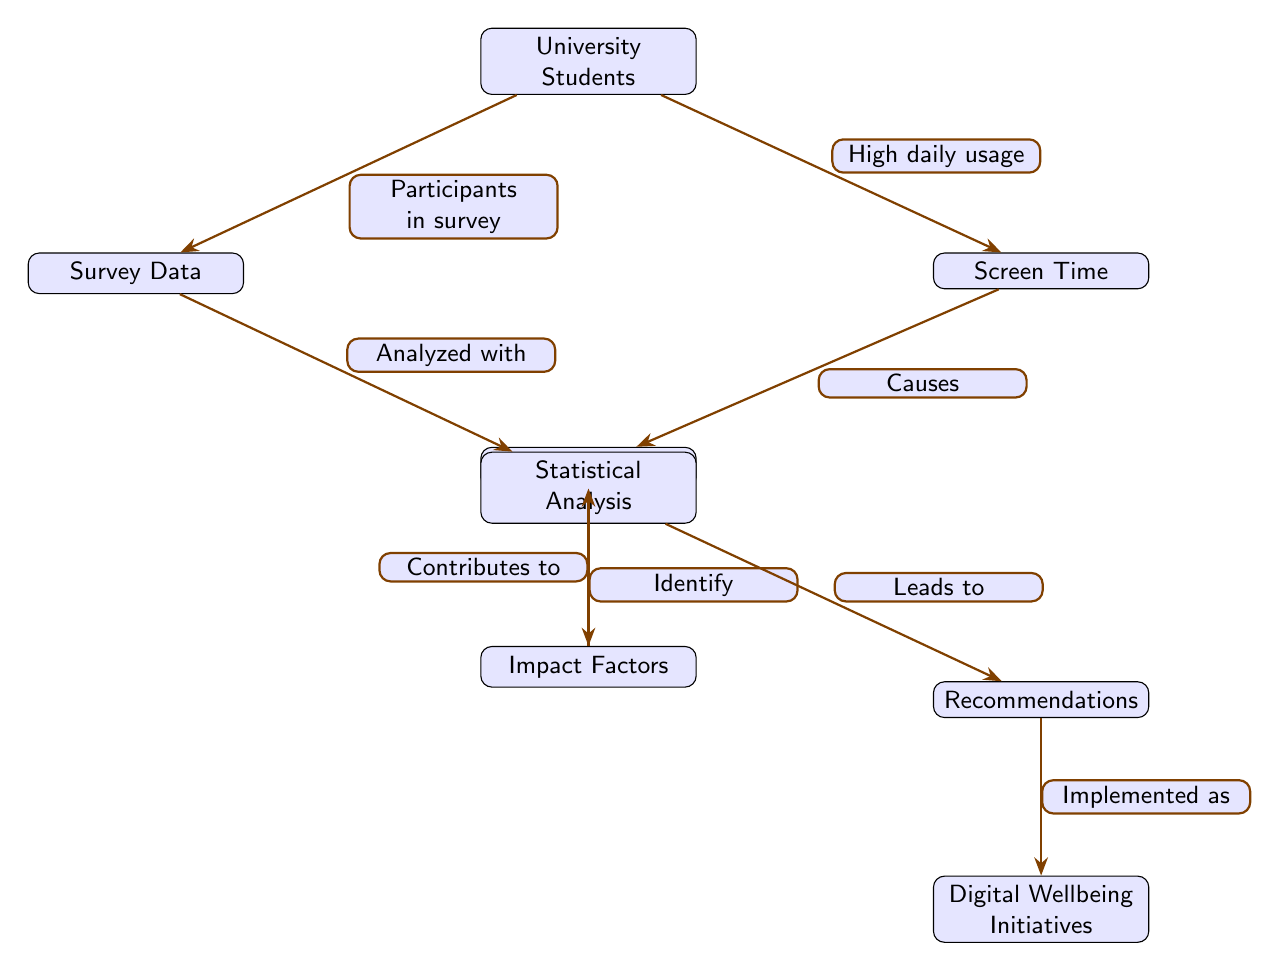What is the main subject of the diagram? The central theme of the diagram is indicated by the first node, which states "University Students." This gives the primary focus of the analysis.
Answer: University Students What are the two main outcomes of high screen time in the diagram? Following the flow from "Screen Time" to the consequences links to the nodes "Blurry Vision" (indicating a direct outcome) and also "Recommendations" (where actions may follow).
Answer: Blurry Vision and Recommendations How many nodes are present in the diagram? Counting all unique elements that represent concepts or categories in the diagram, we find a total of eight nodes listed.
Answer: 8 Which node is connected to both "Survey Data" and "Statistical Analysis"? By examining the connections, "Statistical Analysis" directly connects to "Survey Data," serving as a key link between participant responses and further evaluation.
Answer: Statistical Analysis What causes blurry vision according to the diagram? The connection from the "Screen Time" node to "Blurry Vision" is marked with the word "Causes," indicating that increased screen time leads directly to this symptom.
Answer: Causes What is the relationship between "Statistical Analysis" and "Impact Factors"? The arrow indicates that "Statistical Analysis" helps to "Identify" these factors, indicating a directional influence from one node to the other.
Answer: Identify What leads to "Digital Wellbeing Initiatives"? The flow indicates that from "Recommendations," various strategies or programs termed "Digital Wellbeing Initiatives" are likely to be implemented as a response.
Answer: Implemented as Which node represents data collected from participants? The node labeled "Survey Data" is designated for data collection regarding the experiences and habits of university students participating in the survey.
Answer: Survey Data What connects "Impact Factors" and "Blurry Vision"? The word "Contributes to," signifies a causal link where various factors directly impact the occurrence of blurry vision.
Answer: Contributes to 